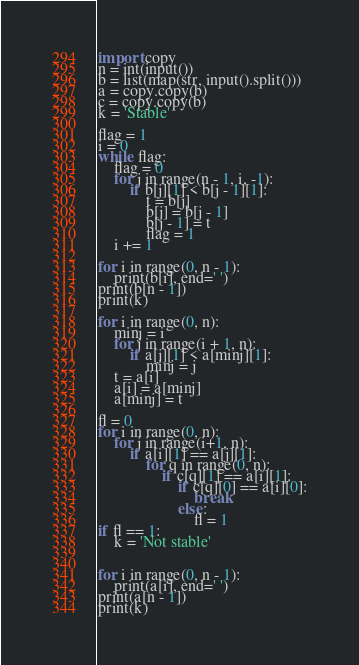<code> <loc_0><loc_0><loc_500><loc_500><_Python_>import copy
n = int(input())
b = list(map(str, input().split()))
a = copy.copy(b)
c = copy.copy(b)
k = 'Stable'

flag = 1
i = 0
while flag:
    flag = 0
    for j in range(n - 1, i, -1):
        if b[j][1] < b[j - 1][1]:
            t = b[j]
            b[j] = b[j - 1]
            b[j - 1] = t
            flag = 1
    i += 1

for i in range(0, n - 1):
    print(b[i], end=' ')
print(b[n - 1])
print(k)

for i in range(0, n):
    minj = i
    for j in range(i + 1, n):
        if a[j][1] < a[minj][1]:
            minj = j
    t = a[i]
    a[i] = a[minj]
    a[minj] = t

fl = 0
for i in range(0, n):
    for j in range(i+1, n):
        if a[i][1] == a[j][1]:
            for q in range(0, n):
                if c[q][1] == a[i][1]:
                    if c[q][0] == a[i][0]:
                        break
                    else:
                        fl = 1
if fl == 1:
    k = 'Not stable'


for i in range(0, n - 1):
    print(a[i], end=' ')
print(a[n - 1])
print(k)
</code> 